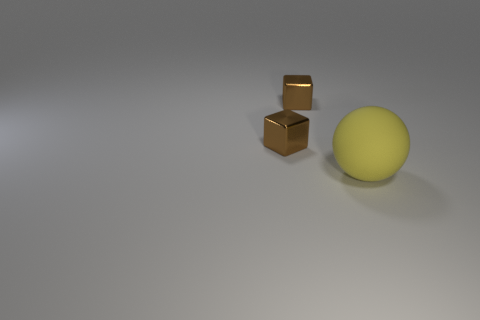Add 1 small metal blocks. How many objects exist? 4 Subtract all blocks. How many objects are left? 1 Add 3 yellow things. How many yellow things are left? 4 Add 1 tiny brown cubes. How many tiny brown cubes exist? 3 Subtract 0 cyan balls. How many objects are left? 3 Subtract all large rubber things. Subtract all big cyan metallic balls. How many objects are left? 2 